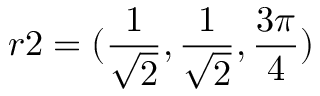<formula> <loc_0><loc_0><loc_500><loc_500>r 2 = ( \frac { 1 } { \sqrt { 2 } } , \frac { 1 } { \sqrt { 2 } } , \frac { 3 \pi } { 4 } )</formula> 